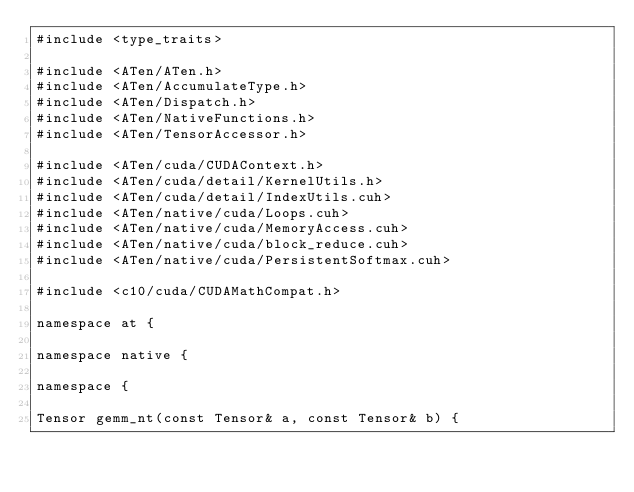Convert code to text. <code><loc_0><loc_0><loc_500><loc_500><_Cuda_>#include <type_traits>

#include <ATen/ATen.h>
#include <ATen/AccumulateType.h>
#include <ATen/Dispatch.h>
#include <ATen/NativeFunctions.h>
#include <ATen/TensorAccessor.h>

#include <ATen/cuda/CUDAContext.h>
#include <ATen/cuda/detail/KernelUtils.h>
#include <ATen/cuda/detail/IndexUtils.cuh>
#include <ATen/native/cuda/Loops.cuh>
#include <ATen/native/cuda/MemoryAccess.cuh>
#include <ATen/native/cuda/block_reduce.cuh>
#include <ATen/native/cuda/PersistentSoftmax.cuh>

#include <c10/cuda/CUDAMathCompat.h>

namespace at {

namespace native {

namespace {

Tensor gemm_nt(const Tensor& a, const Tensor& b) {</code> 